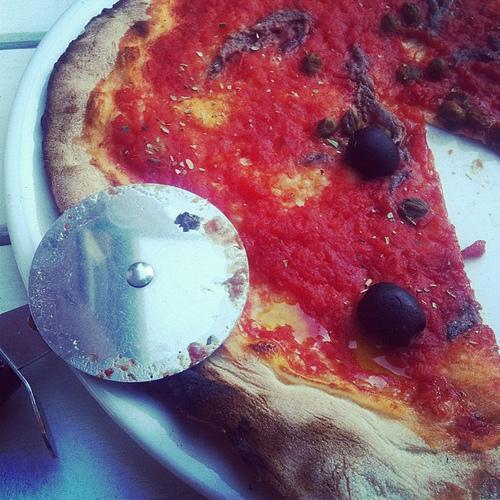How many cutters are there?
Give a very brief answer. 1. 